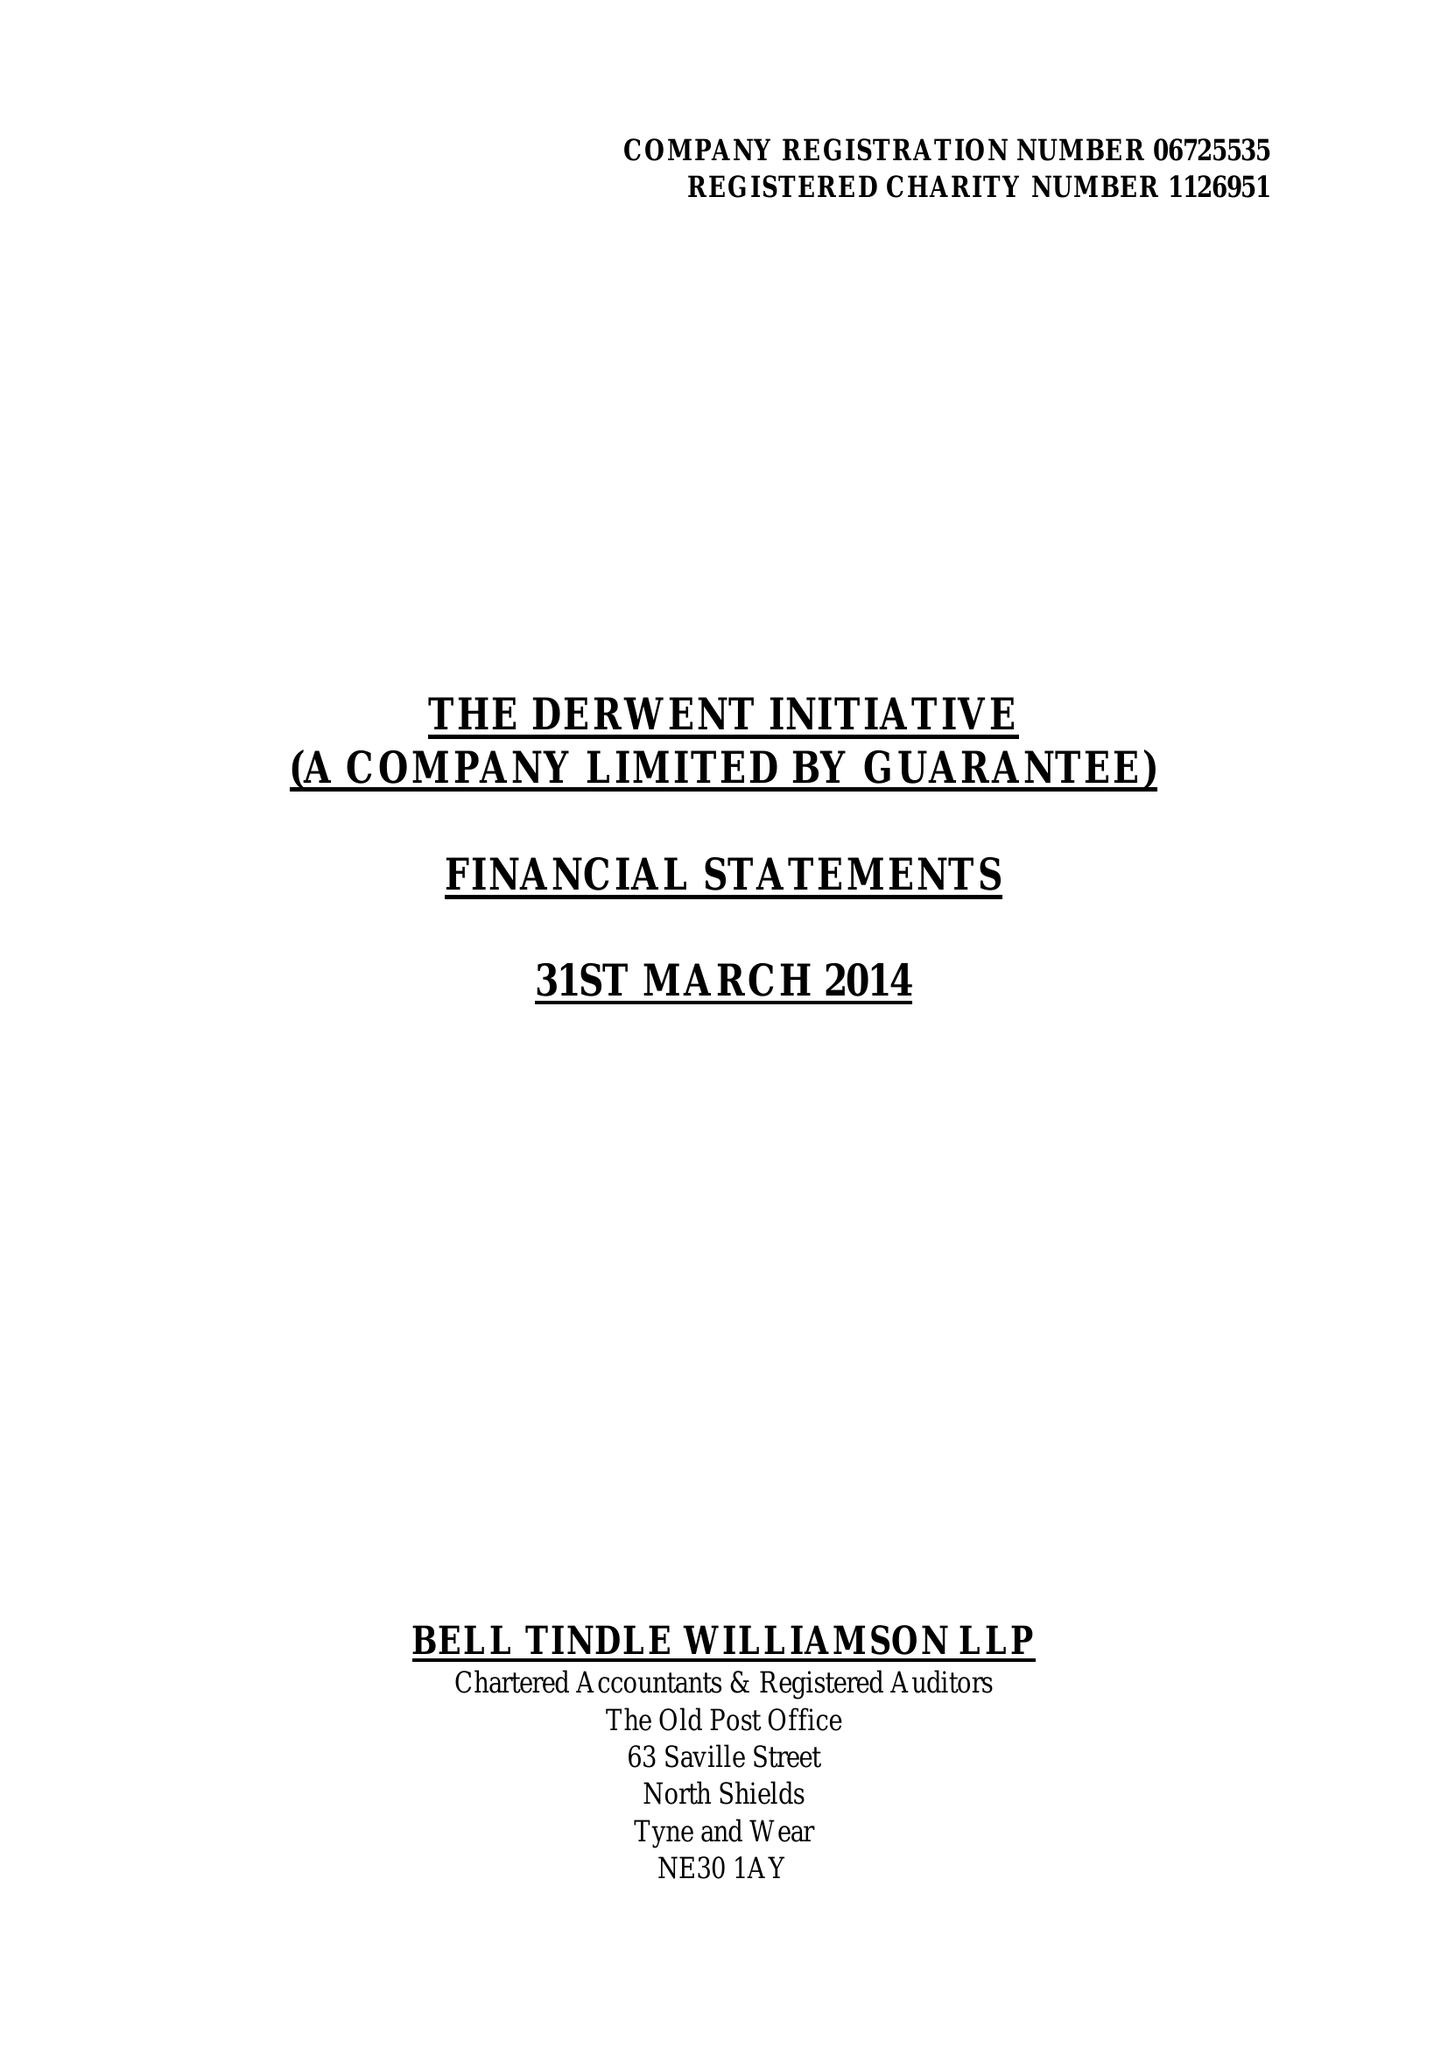What is the value for the address__postcode?
Answer the question using a single word or phrase. NE1 5HX 